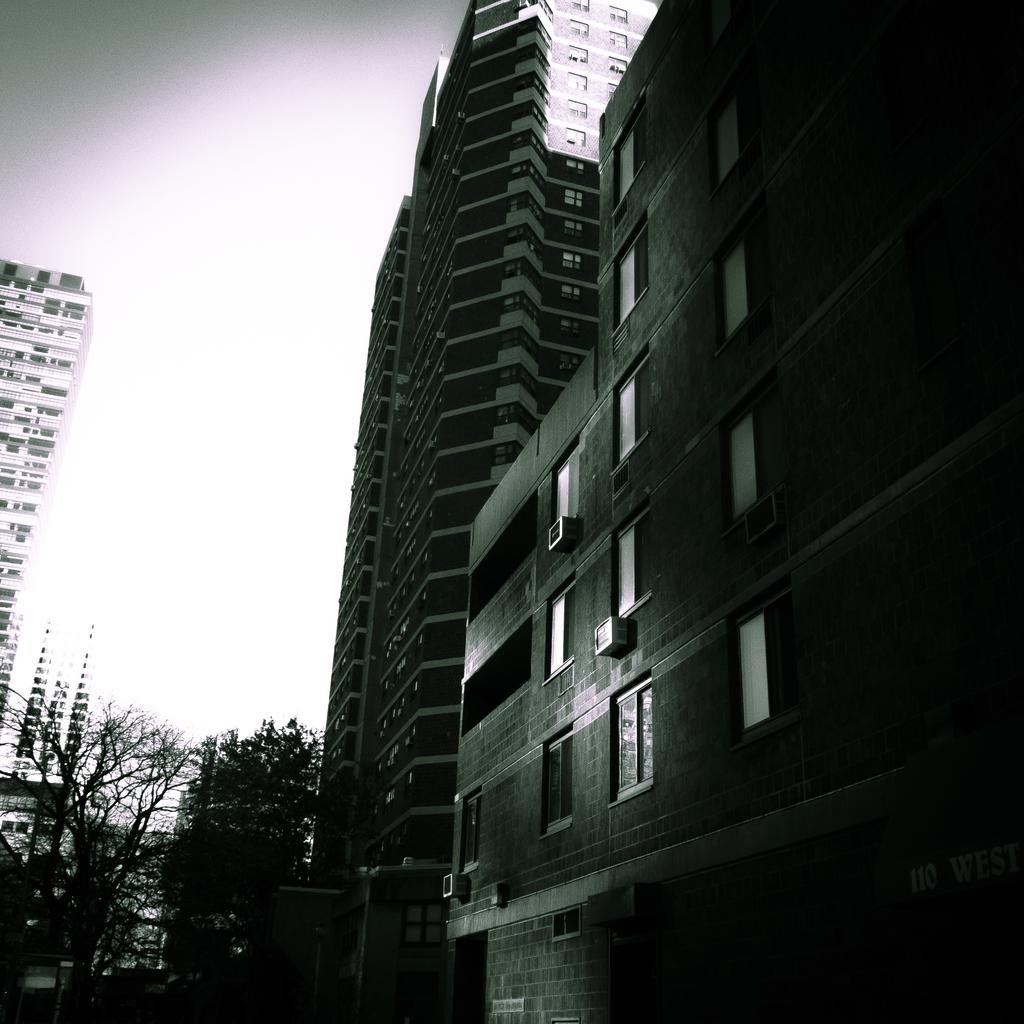What type of structures can be seen in the image? There are buildings in the image. What type of vegetation is present in the image? There are trees in the image. How are the trees positioned in relation to the buildings? The trees are located between the buildings. What type of story is being told by the trees in the image? There is no story being told by the trees in the image; they are simply trees located between buildings. 